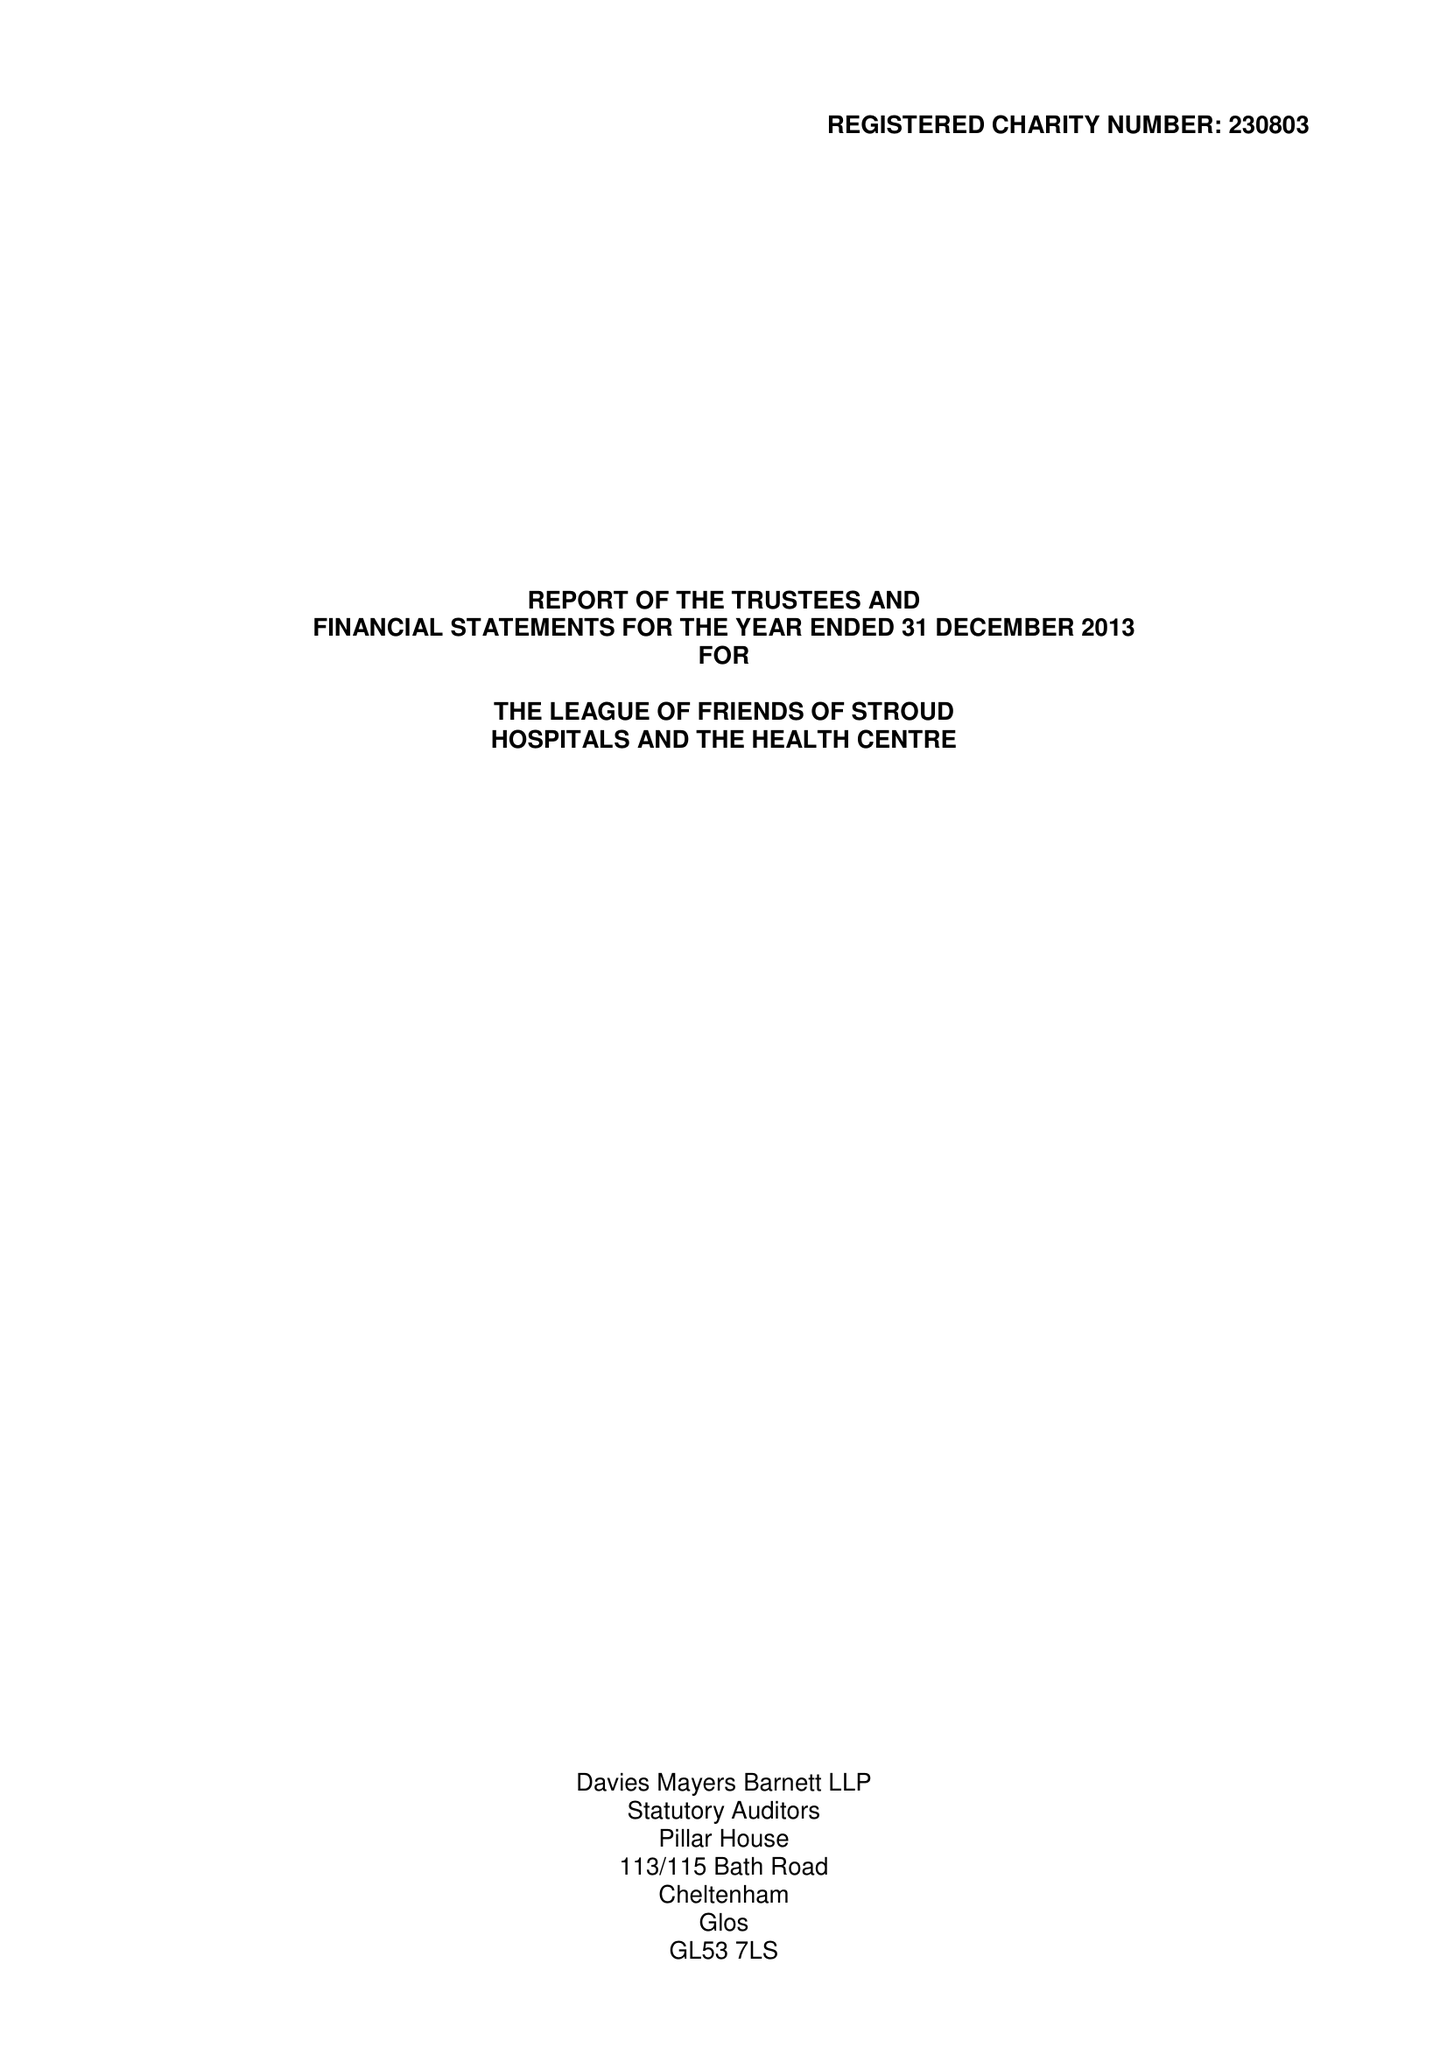What is the value for the income_annually_in_british_pounds?
Answer the question using a single word or phrase. 151517.00 